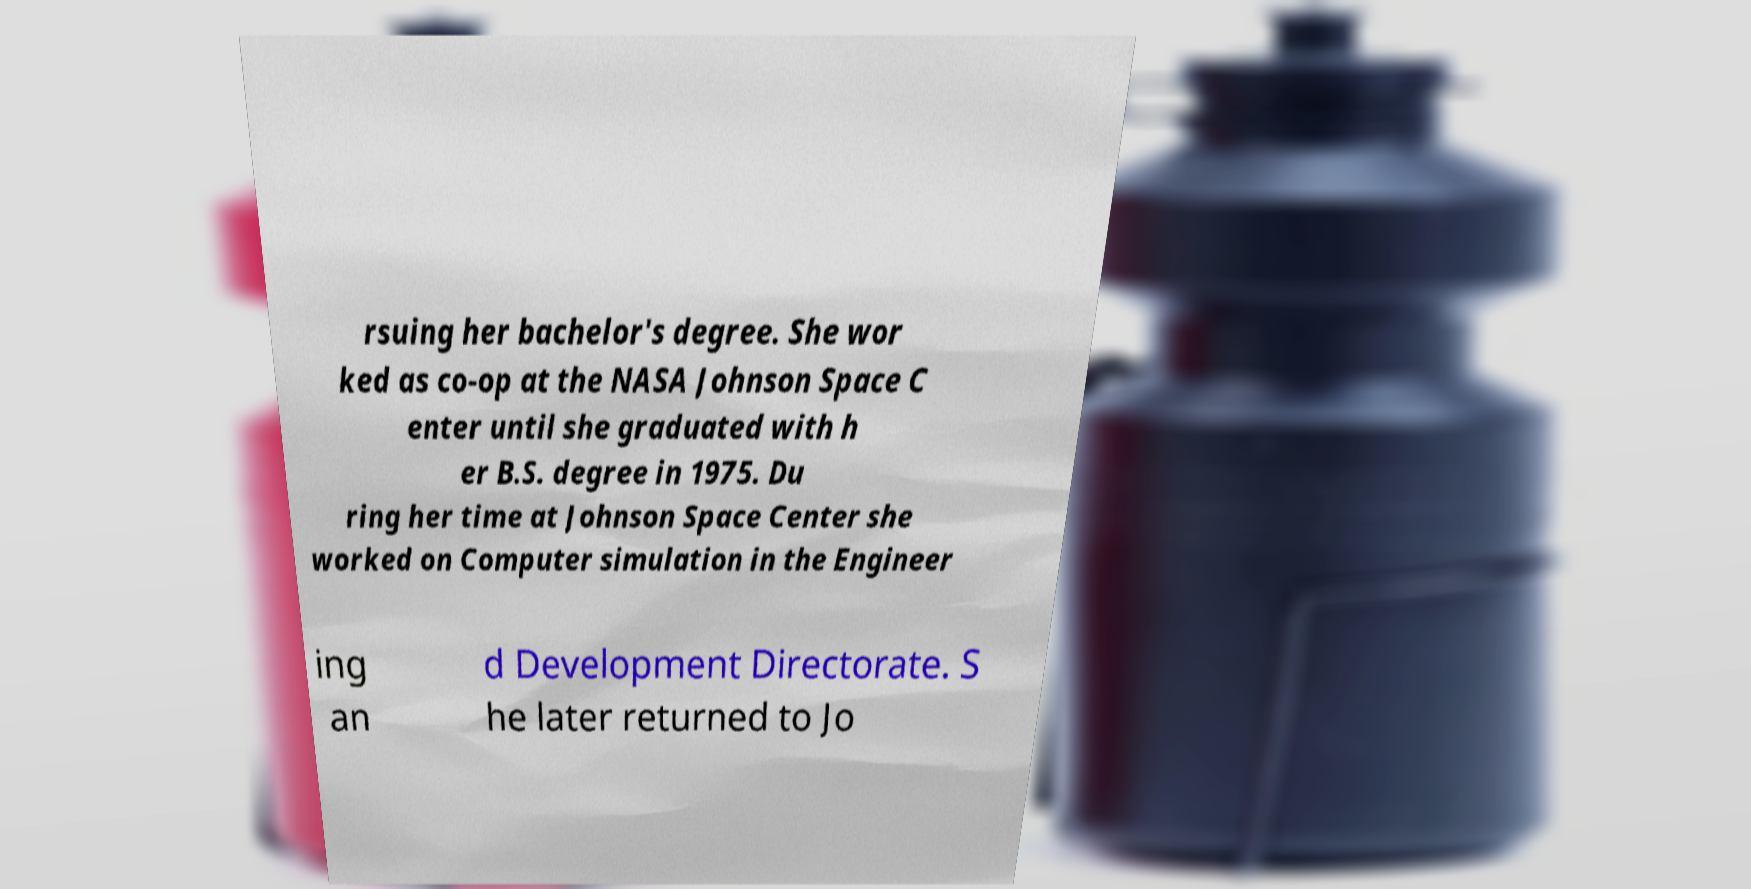There's text embedded in this image that I need extracted. Can you transcribe it verbatim? rsuing her bachelor's degree. She wor ked as co-op at the NASA Johnson Space C enter until she graduated with h er B.S. degree in 1975. Du ring her time at Johnson Space Center she worked on Computer simulation in the Engineer ing an d Development Directorate. S he later returned to Jo 